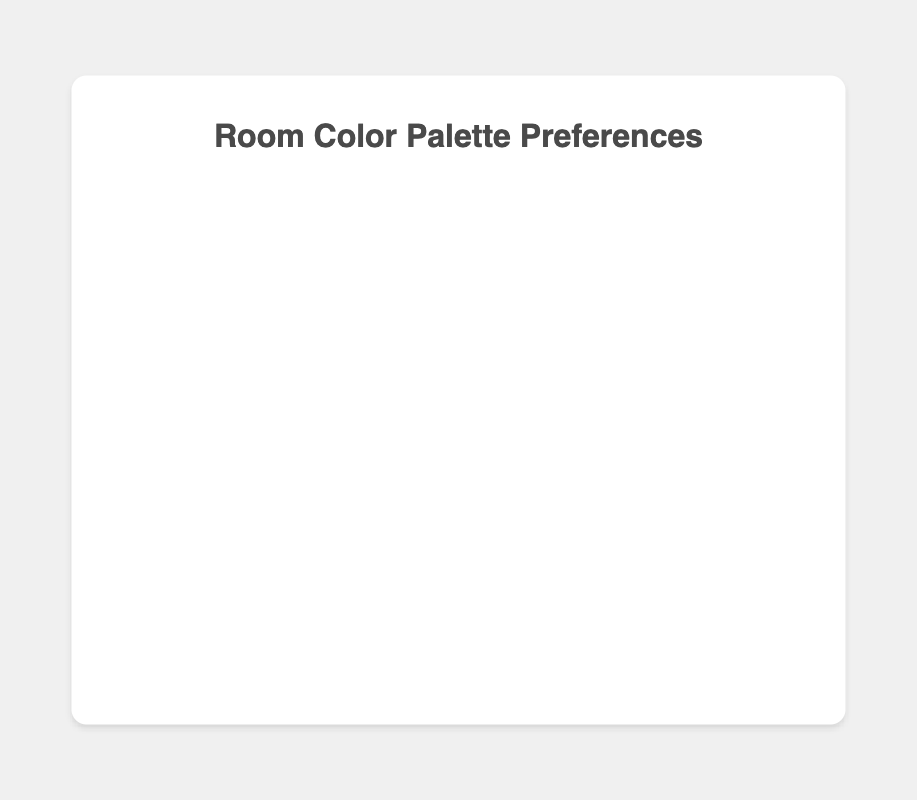Which room has the highest preference for neutral tones? To find out which room has the highest preference for neutral tones, we look at the percentages for each room. The bathroom has 80% preference for neutral tones, which is the highest.
Answer: Bathroom Which room has the lowest preference for vibrant tones? We can find this by checking the vibrant tone percentages for each room. The bathroom again has the lowest at 20%.
Answer: Bathroom Which rooms have an equal preference for neutral and vibrant tones? We need to identify the room where the preference percentages for neutral and vibrant tones are the same. The kitchen has an equal preference of 50% for both.
Answer: Kitchen What's the total percentage of people preferring vibrant tones in the living room and the bedroom combined? To get the total, we add the vibrant tone preferences of both rooms: 40% (living room) + 25% (bedroom) = 65%.
Answer: 65% Which room has a higher preference for vibrant tones: the dining room or the office? We compare the vibrant tone preferences: the dining room has 45% while the office has 35%. Therefore, the dining room has a higher preference for vibrant tones.
Answer: Dining Room Out of all rooms, how many have a greater preference for neutral tones than vibrant tones? We observe the pie charts for each room to determine this. All rooms except the kitchen have a greater preference for neutral tones. So, that makes it 5 rooms.
Answer: 5 Which room has the smallest difference between the preference for neutral tones and vibrant tones? To determine this, we need to calculate the difference for each room and find the smallest one: 
Living Room: 20%, 
Bedroom: 50%, 
Kitchen: 0%, 
Bathroom: 60%, 
Dining Room: 10%, 
Office: 30%. The kitchen has the smallest difference of 0%.
Answer: Kitchen What's the average preference for neutral tones across all rooms? We sum up the neutral tone preferences for all rooms and divide by the number of rooms: (60% + 75% + 50% + 80% + 55% + 65%) / 6 = 64.17%.
Answer: 64.17% Which room's preferences are closest to being balanced between neutral and vibrant tones? To find this, we look for the room where the two preferences are closest in percentage: 
Living Room: 20% different,
Bedroom: 50% different,
Kitchen: 0% different,
Bathroom: 60% different,
Dining Room: 10% different,
Office: 30% different. The kitchen is perfectly balanced with a 0% difference.
Answer: Kitchen 